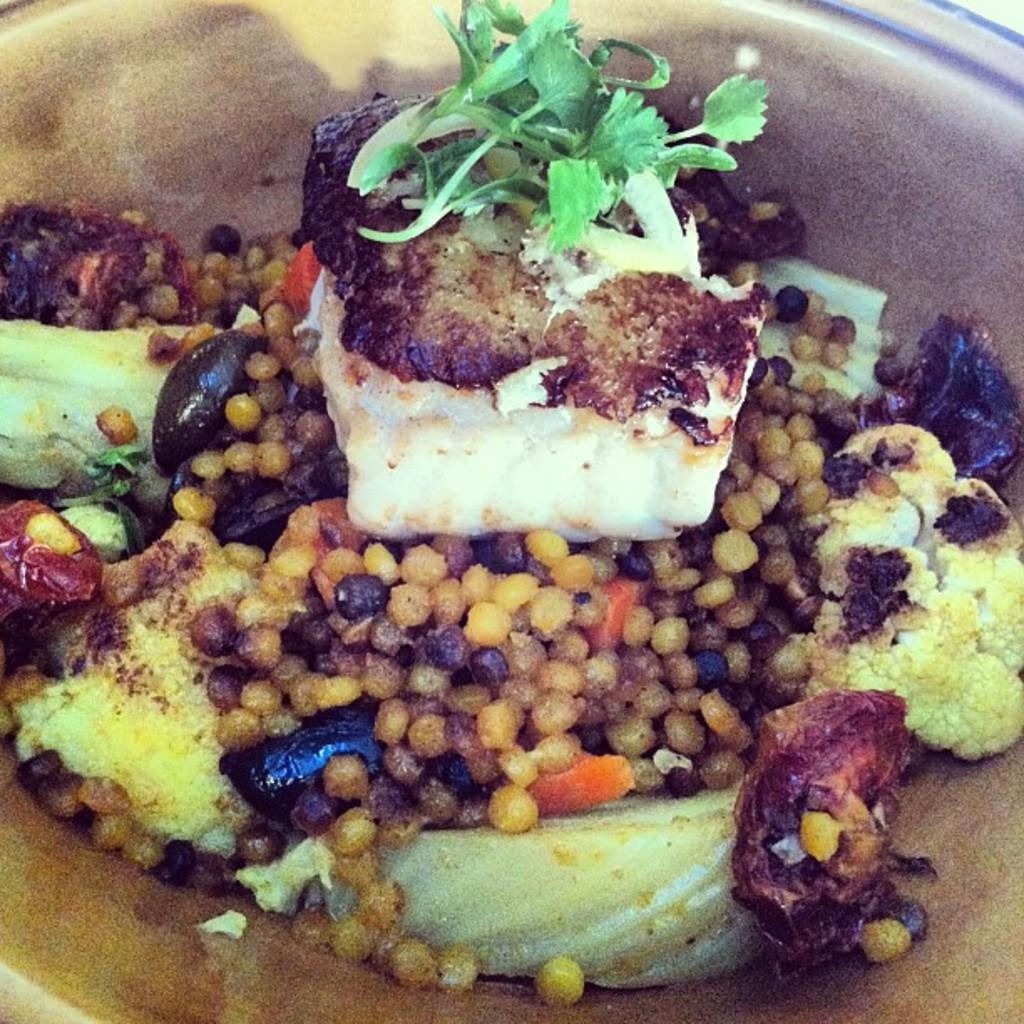What object is present in the image that is typically used for serving food? There is a plate in the image. What is on the plate that is visible in the image? There is a food item on the plate. How many clocks are visible on the plate in the image? There are no clocks visible on the plate in the image. What is the starting point for eating the food item on the plate in the image? The image does not provide information about the starting point for eating the food item. 